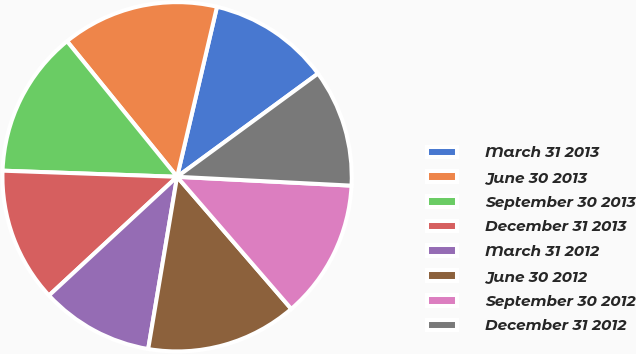<chart> <loc_0><loc_0><loc_500><loc_500><pie_chart><fcel>March 31 2013<fcel>June 30 2013<fcel>September 30 2013<fcel>December 31 2013<fcel>March 31 2012<fcel>June 30 2012<fcel>September 30 2012<fcel>December 31 2012<nl><fcel>11.27%<fcel>14.52%<fcel>13.59%<fcel>12.45%<fcel>10.46%<fcel>13.99%<fcel>12.85%<fcel>10.87%<nl></chart> 